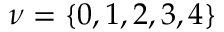<formula> <loc_0><loc_0><loc_500><loc_500>\nu = \{ 0 , 1 , 2 , 3 , 4 \}</formula> 